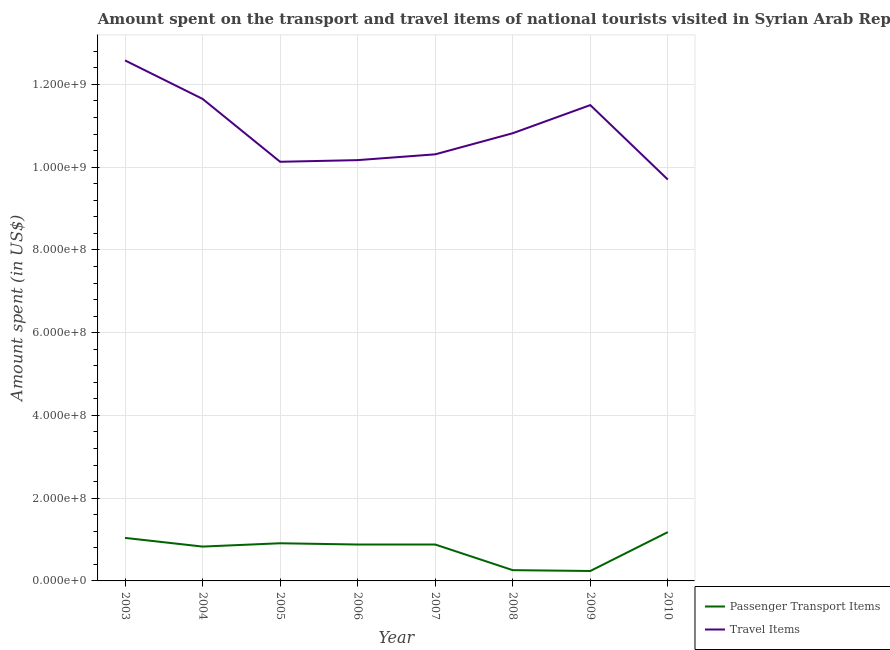Is the number of lines equal to the number of legend labels?
Provide a succinct answer. Yes. What is the amount spent in travel items in 2003?
Offer a terse response. 1.26e+09. Across all years, what is the maximum amount spent on passenger transport items?
Offer a terse response. 1.18e+08. Across all years, what is the minimum amount spent on passenger transport items?
Your answer should be compact. 2.40e+07. In which year was the amount spent on passenger transport items maximum?
Offer a very short reply. 2010. In which year was the amount spent on passenger transport items minimum?
Your response must be concise. 2009. What is the total amount spent on passenger transport items in the graph?
Provide a short and direct response. 6.22e+08. What is the difference between the amount spent in travel items in 2003 and that in 2006?
Ensure brevity in your answer.  2.41e+08. What is the difference between the amount spent on passenger transport items in 2007 and the amount spent in travel items in 2005?
Your response must be concise. -9.25e+08. What is the average amount spent in travel items per year?
Your answer should be very brief. 1.09e+09. In the year 2010, what is the difference between the amount spent in travel items and amount spent on passenger transport items?
Offer a terse response. 8.52e+08. What is the ratio of the amount spent in travel items in 2006 to that in 2007?
Provide a short and direct response. 0.99. Is the difference between the amount spent in travel items in 2003 and 2010 greater than the difference between the amount spent on passenger transport items in 2003 and 2010?
Provide a succinct answer. Yes. What is the difference between the highest and the second highest amount spent on passenger transport items?
Ensure brevity in your answer.  1.40e+07. What is the difference between the highest and the lowest amount spent on passenger transport items?
Offer a terse response. 9.40e+07. In how many years, is the amount spent on passenger transport items greater than the average amount spent on passenger transport items taken over all years?
Keep it short and to the point. 6. Is the sum of the amount spent in travel items in 2003 and 2005 greater than the maximum amount spent on passenger transport items across all years?
Offer a terse response. Yes. Does the amount spent in travel items monotonically increase over the years?
Provide a short and direct response. No. How many years are there in the graph?
Provide a succinct answer. 8. Are the values on the major ticks of Y-axis written in scientific E-notation?
Offer a terse response. Yes. Where does the legend appear in the graph?
Keep it short and to the point. Bottom right. What is the title of the graph?
Your answer should be very brief. Amount spent on the transport and travel items of national tourists visited in Syrian Arab Republic. Does "GDP at market prices" appear as one of the legend labels in the graph?
Your answer should be compact. No. What is the label or title of the Y-axis?
Your answer should be compact. Amount spent (in US$). What is the Amount spent (in US$) of Passenger Transport Items in 2003?
Ensure brevity in your answer.  1.04e+08. What is the Amount spent (in US$) in Travel Items in 2003?
Your response must be concise. 1.26e+09. What is the Amount spent (in US$) in Passenger Transport Items in 2004?
Your answer should be compact. 8.30e+07. What is the Amount spent (in US$) in Travel Items in 2004?
Provide a succinct answer. 1.16e+09. What is the Amount spent (in US$) of Passenger Transport Items in 2005?
Give a very brief answer. 9.10e+07. What is the Amount spent (in US$) of Travel Items in 2005?
Your response must be concise. 1.01e+09. What is the Amount spent (in US$) of Passenger Transport Items in 2006?
Ensure brevity in your answer.  8.80e+07. What is the Amount spent (in US$) of Travel Items in 2006?
Provide a short and direct response. 1.02e+09. What is the Amount spent (in US$) of Passenger Transport Items in 2007?
Make the answer very short. 8.80e+07. What is the Amount spent (in US$) of Travel Items in 2007?
Provide a succinct answer. 1.03e+09. What is the Amount spent (in US$) in Passenger Transport Items in 2008?
Make the answer very short. 2.60e+07. What is the Amount spent (in US$) of Travel Items in 2008?
Offer a very short reply. 1.08e+09. What is the Amount spent (in US$) of Passenger Transport Items in 2009?
Provide a succinct answer. 2.40e+07. What is the Amount spent (in US$) of Travel Items in 2009?
Offer a very short reply. 1.15e+09. What is the Amount spent (in US$) in Passenger Transport Items in 2010?
Provide a succinct answer. 1.18e+08. What is the Amount spent (in US$) in Travel Items in 2010?
Make the answer very short. 9.70e+08. Across all years, what is the maximum Amount spent (in US$) of Passenger Transport Items?
Offer a very short reply. 1.18e+08. Across all years, what is the maximum Amount spent (in US$) of Travel Items?
Keep it short and to the point. 1.26e+09. Across all years, what is the minimum Amount spent (in US$) in Passenger Transport Items?
Offer a very short reply. 2.40e+07. Across all years, what is the minimum Amount spent (in US$) in Travel Items?
Keep it short and to the point. 9.70e+08. What is the total Amount spent (in US$) of Passenger Transport Items in the graph?
Make the answer very short. 6.22e+08. What is the total Amount spent (in US$) of Travel Items in the graph?
Offer a terse response. 8.69e+09. What is the difference between the Amount spent (in US$) of Passenger Transport Items in 2003 and that in 2004?
Offer a terse response. 2.10e+07. What is the difference between the Amount spent (in US$) in Travel Items in 2003 and that in 2004?
Make the answer very short. 9.30e+07. What is the difference between the Amount spent (in US$) of Passenger Transport Items in 2003 and that in 2005?
Your answer should be compact. 1.30e+07. What is the difference between the Amount spent (in US$) of Travel Items in 2003 and that in 2005?
Offer a very short reply. 2.45e+08. What is the difference between the Amount spent (in US$) of Passenger Transport Items in 2003 and that in 2006?
Give a very brief answer. 1.60e+07. What is the difference between the Amount spent (in US$) of Travel Items in 2003 and that in 2006?
Keep it short and to the point. 2.41e+08. What is the difference between the Amount spent (in US$) of Passenger Transport Items in 2003 and that in 2007?
Your answer should be very brief. 1.60e+07. What is the difference between the Amount spent (in US$) in Travel Items in 2003 and that in 2007?
Your answer should be very brief. 2.27e+08. What is the difference between the Amount spent (in US$) of Passenger Transport Items in 2003 and that in 2008?
Offer a very short reply. 7.80e+07. What is the difference between the Amount spent (in US$) of Travel Items in 2003 and that in 2008?
Keep it short and to the point. 1.76e+08. What is the difference between the Amount spent (in US$) in Passenger Transport Items in 2003 and that in 2009?
Give a very brief answer. 8.00e+07. What is the difference between the Amount spent (in US$) of Travel Items in 2003 and that in 2009?
Your answer should be compact. 1.08e+08. What is the difference between the Amount spent (in US$) of Passenger Transport Items in 2003 and that in 2010?
Give a very brief answer. -1.40e+07. What is the difference between the Amount spent (in US$) of Travel Items in 2003 and that in 2010?
Make the answer very short. 2.88e+08. What is the difference between the Amount spent (in US$) in Passenger Transport Items in 2004 and that in 2005?
Keep it short and to the point. -8.00e+06. What is the difference between the Amount spent (in US$) of Travel Items in 2004 and that in 2005?
Keep it short and to the point. 1.52e+08. What is the difference between the Amount spent (in US$) of Passenger Transport Items in 2004 and that in 2006?
Ensure brevity in your answer.  -5.00e+06. What is the difference between the Amount spent (in US$) in Travel Items in 2004 and that in 2006?
Provide a short and direct response. 1.48e+08. What is the difference between the Amount spent (in US$) of Passenger Transport Items in 2004 and that in 2007?
Your answer should be compact. -5.00e+06. What is the difference between the Amount spent (in US$) of Travel Items in 2004 and that in 2007?
Make the answer very short. 1.34e+08. What is the difference between the Amount spent (in US$) of Passenger Transport Items in 2004 and that in 2008?
Offer a terse response. 5.70e+07. What is the difference between the Amount spent (in US$) of Travel Items in 2004 and that in 2008?
Ensure brevity in your answer.  8.30e+07. What is the difference between the Amount spent (in US$) of Passenger Transport Items in 2004 and that in 2009?
Give a very brief answer. 5.90e+07. What is the difference between the Amount spent (in US$) in Travel Items in 2004 and that in 2009?
Give a very brief answer. 1.50e+07. What is the difference between the Amount spent (in US$) in Passenger Transport Items in 2004 and that in 2010?
Your answer should be very brief. -3.50e+07. What is the difference between the Amount spent (in US$) of Travel Items in 2004 and that in 2010?
Provide a succinct answer. 1.95e+08. What is the difference between the Amount spent (in US$) in Travel Items in 2005 and that in 2007?
Ensure brevity in your answer.  -1.80e+07. What is the difference between the Amount spent (in US$) of Passenger Transport Items in 2005 and that in 2008?
Provide a succinct answer. 6.50e+07. What is the difference between the Amount spent (in US$) in Travel Items in 2005 and that in 2008?
Provide a succinct answer. -6.90e+07. What is the difference between the Amount spent (in US$) of Passenger Transport Items in 2005 and that in 2009?
Ensure brevity in your answer.  6.70e+07. What is the difference between the Amount spent (in US$) of Travel Items in 2005 and that in 2009?
Your answer should be very brief. -1.37e+08. What is the difference between the Amount spent (in US$) of Passenger Transport Items in 2005 and that in 2010?
Provide a short and direct response. -2.70e+07. What is the difference between the Amount spent (in US$) of Travel Items in 2005 and that in 2010?
Offer a very short reply. 4.30e+07. What is the difference between the Amount spent (in US$) of Passenger Transport Items in 2006 and that in 2007?
Give a very brief answer. 0. What is the difference between the Amount spent (in US$) in Travel Items in 2006 and that in 2007?
Provide a short and direct response. -1.40e+07. What is the difference between the Amount spent (in US$) of Passenger Transport Items in 2006 and that in 2008?
Give a very brief answer. 6.20e+07. What is the difference between the Amount spent (in US$) of Travel Items in 2006 and that in 2008?
Ensure brevity in your answer.  -6.50e+07. What is the difference between the Amount spent (in US$) of Passenger Transport Items in 2006 and that in 2009?
Give a very brief answer. 6.40e+07. What is the difference between the Amount spent (in US$) of Travel Items in 2006 and that in 2009?
Your response must be concise. -1.33e+08. What is the difference between the Amount spent (in US$) in Passenger Transport Items in 2006 and that in 2010?
Make the answer very short. -3.00e+07. What is the difference between the Amount spent (in US$) in Travel Items in 2006 and that in 2010?
Make the answer very short. 4.70e+07. What is the difference between the Amount spent (in US$) of Passenger Transport Items in 2007 and that in 2008?
Offer a very short reply. 6.20e+07. What is the difference between the Amount spent (in US$) of Travel Items in 2007 and that in 2008?
Keep it short and to the point. -5.10e+07. What is the difference between the Amount spent (in US$) of Passenger Transport Items in 2007 and that in 2009?
Offer a terse response. 6.40e+07. What is the difference between the Amount spent (in US$) in Travel Items in 2007 and that in 2009?
Keep it short and to the point. -1.19e+08. What is the difference between the Amount spent (in US$) of Passenger Transport Items in 2007 and that in 2010?
Your answer should be compact. -3.00e+07. What is the difference between the Amount spent (in US$) of Travel Items in 2007 and that in 2010?
Your answer should be compact. 6.10e+07. What is the difference between the Amount spent (in US$) of Passenger Transport Items in 2008 and that in 2009?
Your answer should be very brief. 2.00e+06. What is the difference between the Amount spent (in US$) of Travel Items in 2008 and that in 2009?
Keep it short and to the point. -6.80e+07. What is the difference between the Amount spent (in US$) of Passenger Transport Items in 2008 and that in 2010?
Offer a very short reply. -9.20e+07. What is the difference between the Amount spent (in US$) in Travel Items in 2008 and that in 2010?
Your response must be concise. 1.12e+08. What is the difference between the Amount spent (in US$) of Passenger Transport Items in 2009 and that in 2010?
Keep it short and to the point. -9.40e+07. What is the difference between the Amount spent (in US$) of Travel Items in 2009 and that in 2010?
Your answer should be very brief. 1.80e+08. What is the difference between the Amount spent (in US$) of Passenger Transport Items in 2003 and the Amount spent (in US$) of Travel Items in 2004?
Your answer should be compact. -1.06e+09. What is the difference between the Amount spent (in US$) of Passenger Transport Items in 2003 and the Amount spent (in US$) of Travel Items in 2005?
Ensure brevity in your answer.  -9.09e+08. What is the difference between the Amount spent (in US$) of Passenger Transport Items in 2003 and the Amount spent (in US$) of Travel Items in 2006?
Provide a short and direct response. -9.13e+08. What is the difference between the Amount spent (in US$) of Passenger Transport Items in 2003 and the Amount spent (in US$) of Travel Items in 2007?
Provide a short and direct response. -9.27e+08. What is the difference between the Amount spent (in US$) of Passenger Transport Items in 2003 and the Amount spent (in US$) of Travel Items in 2008?
Your answer should be very brief. -9.78e+08. What is the difference between the Amount spent (in US$) in Passenger Transport Items in 2003 and the Amount spent (in US$) in Travel Items in 2009?
Provide a short and direct response. -1.05e+09. What is the difference between the Amount spent (in US$) in Passenger Transport Items in 2003 and the Amount spent (in US$) in Travel Items in 2010?
Keep it short and to the point. -8.66e+08. What is the difference between the Amount spent (in US$) of Passenger Transport Items in 2004 and the Amount spent (in US$) of Travel Items in 2005?
Provide a succinct answer. -9.30e+08. What is the difference between the Amount spent (in US$) in Passenger Transport Items in 2004 and the Amount spent (in US$) in Travel Items in 2006?
Your answer should be compact. -9.34e+08. What is the difference between the Amount spent (in US$) in Passenger Transport Items in 2004 and the Amount spent (in US$) in Travel Items in 2007?
Offer a terse response. -9.48e+08. What is the difference between the Amount spent (in US$) of Passenger Transport Items in 2004 and the Amount spent (in US$) of Travel Items in 2008?
Offer a very short reply. -9.99e+08. What is the difference between the Amount spent (in US$) of Passenger Transport Items in 2004 and the Amount spent (in US$) of Travel Items in 2009?
Give a very brief answer. -1.07e+09. What is the difference between the Amount spent (in US$) of Passenger Transport Items in 2004 and the Amount spent (in US$) of Travel Items in 2010?
Your answer should be very brief. -8.87e+08. What is the difference between the Amount spent (in US$) in Passenger Transport Items in 2005 and the Amount spent (in US$) in Travel Items in 2006?
Ensure brevity in your answer.  -9.26e+08. What is the difference between the Amount spent (in US$) of Passenger Transport Items in 2005 and the Amount spent (in US$) of Travel Items in 2007?
Make the answer very short. -9.40e+08. What is the difference between the Amount spent (in US$) in Passenger Transport Items in 2005 and the Amount spent (in US$) in Travel Items in 2008?
Your answer should be compact. -9.91e+08. What is the difference between the Amount spent (in US$) of Passenger Transport Items in 2005 and the Amount spent (in US$) of Travel Items in 2009?
Your response must be concise. -1.06e+09. What is the difference between the Amount spent (in US$) in Passenger Transport Items in 2005 and the Amount spent (in US$) in Travel Items in 2010?
Provide a succinct answer. -8.79e+08. What is the difference between the Amount spent (in US$) of Passenger Transport Items in 2006 and the Amount spent (in US$) of Travel Items in 2007?
Provide a short and direct response. -9.43e+08. What is the difference between the Amount spent (in US$) in Passenger Transport Items in 2006 and the Amount spent (in US$) in Travel Items in 2008?
Offer a terse response. -9.94e+08. What is the difference between the Amount spent (in US$) of Passenger Transport Items in 2006 and the Amount spent (in US$) of Travel Items in 2009?
Keep it short and to the point. -1.06e+09. What is the difference between the Amount spent (in US$) of Passenger Transport Items in 2006 and the Amount spent (in US$) of Travel Items in 2010?
Give a very brief answer. -8.82e+08. What is the difference between the Amount spent (in US$) in Passenger Transport Items in 2007 and the Amount spent (in US$) in Travel Items in 2008?
Your answer should be compact. -9.94e+08. What is the difference between the Amount spent (in US$) of Passenger Transport Items in 2007 and the Amount spent (in US$) of Travel Items in 2009?
Make the answer very short. -1.06e+09. What is the difference between the Amount spent (in US$) of Passenger Transport Items in 2007 and the Amount spent (in US$) of Travel Items in 2010?
Make the answer very short. -8.82e+08. What is the difference between the Amount spent (in US$) of Passenger Transport Items in 2008 and the Amount spent (in US$) of Travel Items in 2009?
Offer a terse response. -1.12e+09. What is the difference between the Amount spent (in US$) of Passenger Transport Items in 2008 and the Amount spent (in US$) of Travel Items in 2010?
Offer a very short reply. -9.44e+08. What is the difference between the Amount spent (in US$) in Passenger Transport Items in 2009 and the Amount spent (in US$) in Travel Items in 2010?
Offer a terse response. -9.46e+08. What is the average Amount spent (in US$) in Passenger Transport Items per year?
Your answer should be compact. 7.78e+07. What is the average Amount spent (in US$) of Travel Items per year?
Provide a succinct answer. 1.09e+09. In the year 2003, what is the difference between the Amount spent (in US$) of Passenger Transport Items and Amount spent (in US$) of Travel Items?
Your answer should be compact. -1.15e+09. In the year 2004, what is the difference between the Amount spent (in US$) in Passenger Transport Items and Amount spent (in US$) in Travel Items?
Your response must be concise. -1.08e+09. In the year 2005, what is the difference between the Amount spent (in US$) in Passenger Transport Items and Amount spent (in US$) in Travel Items?
Your response must be concise. -9.22e+08. In the year 2006, what is the difference between the Amount spent (in US$) in Passenger Transport Items and Amount spent (in US$) in Travel Items?
Make the answer very short. -9.29e+08. In the year 2007, what is the difference between the Amount spent (in US$) in Passenger Transport Items and Amount spent (in US$) in Travel Items?
Your response must be concise. -9.43e+08. In the year 2008, what is the difference between the Amount spent (in US$) in Passenger Transport Items and Amount spent (in US$) in Travel Items?
Give a very brief answer. -1.06e+09. In the year 2009, what is the difference between the Amount spent (in US$) in Passenger Transport Items and Amount spent (in US$) in Travel Items?
Keep it short and to the point. -1.13e+09. In the year 2010, what is the difference between the Amount spent (in US$) in Passenger Transport Items and Amount spent (in US$) in Travel Items?
Provide a short and direct response. -8.52e+08. What is the ratio of the Amount spent (in US$) of Passenger Transport Items in 2003 to that in 2004?
Keep it short and to the point. 1.25. What is the ratio of the Amount spent (in US$) in Travel Items in 2003 to that in 2004?
Provide a short and direct response. 1.08. What is the ratio of the Amount spent (in US$) of Travel Items in 2003 to that in 2005?
Make the answer very short. 1.24. What is the ratio of the Amount spent (in US$) in Passenger Transport Items in 2003 to that in 2006?
Give a very brief answer. 1.18. What is the ratio of the Amount spent (in US$) in Travel Items in 2003 to that in 2006?
Provide a succinct answer. 1.24. What is the ratio of the Amount spent (in US$) of Passenger Transport Items in 2003 to that in 2007?
Make the answer very short. 1.18. What is the ratio of the Amount spent (in US$) in Travel Items in 2003 to that in 2007?
Your answer should be compact. 1.22. What is the ratio of the Amount spent (in US$) in Passenger Transport Items in 2003 to that in 2008?
Provide a short and direct response. 4. What is the ratio of the Amount spent (in US$) in Travel Items in 2003 to that in 2008?
Provide a succinct answer. 1.16. What is the ratio of the Amount spent (in US$) in Passenger Transport Items in 2003 to that in 2009?
Offer a very short reply. 4.33. What is the ratio of the Amount spent (in US$) of Travel Items in 2003 to that in 2009?
Your response must be concise. 1.09. What is the ratio of the Amount spent (in US$) of Passenger Transport Items in 2003 to that in 2010?
Your answer should be very brief. 0.88. What is the ratio of the Amount spent (in US$) of Travel Items in 2003 to that in 2010?
Offer a very short reply. 1.3. What is the ratio of the Amount spent (in US$) in Passenger Transport Items in 2004 to that in 2005?
Make the answer very short. 0.91. What is the ratio of the Amount spent (in US$) of Travel Items in 2004 to that in 2005?
Offer a very short reply. 1.15. What is the ratio of the Amount spent (in US$) of Passenger Transport Items in 2004 to that in 2006?
Provide a succinct answer. 0.94. What is the ratio of the Amount spent (in US$) in Travel Items in 2004 to that in 2006?
Ensure brevity in your answer.  1.15. What is the ratio of the Amount spent (in US$) in Passenger Transport Items in 2004 to that in 2007?
Give a very brief answer. 0.94. What is the ratio of the Amount spent (in US$) of Travel Items in 2004 to that in 2007?
Your response must be concise. 1.13. What is the ratio of the Amount spent (in US$) in Passenger Transport Items in 2004 to that in 2008?
Your response must be concise. 3.19. What is the ratio of the Amount spent (in US$) in Travel Items in 2004 to that in 2008?
Your response must be concise. 1.08. What is the ratio of the Amount spent (in US$) of Passenger Transport Items in 2004 to that in 2009?
Provide a succinct answer. 3.46. What is the ratio of the Amount spent (in US$) of Travel Items in 2004 to that in 2009?
Provide a succinct answer. 1.01. What is the ratio of the Amount spent (in US$) of Passenger Transport Items in 2004 to that in 2010?
Provide a succinct answer. 0.7. What is the ratio of the Amount spent (in US$) of Travel Items in 2004 to that in 2010?
Make the answer very short. 1.2. What is the ratio of the Amount spent (in US$) in Passenger Transport Items in 2005 to that in 2006?
Ensure brevity in your answer.  1.03. What is the ratio of the Amount spent (in US$) in Passenger Transport Items in 2005 to that in 2007?
Provide a short and direct response. 1.03. What is the ratio of the Amount spent (in US$) in Travel Items in 2005 to that in 2007?
Your response must be concise. 0.98. What is the ratio of the Amount spent (in US$) of Passenger Transport Items in 2005 to that in 2008?
Provide a succinct answer. 3.5. What is the ratio of the Amount spent (in US$) in Travel Items in 2005 to that in 2008?
Your answer should be compact. 0.94. What is the ratio of the Amount spent (in US$) in Passenger Transport Items in 2005 to that in 2009?
Your answer should be very brief. 3.79. What is the ratio of the Amount spent (in US$) in Travel Items in 2005 to that in 2009?
Your answer should be very brief. 0.88. What is the ratio of the Amount spent (in US$) of Passenger Transport Items in 2005 to that in 2010?
Your answer should be very brief. 0.77. What is the ratio of the Amount spent (in US$) of Travel Items in 2005 to that in 2010?
Keep it short and to the point. 1.04. What is the ratio of the Amount spent (in US$) in Travel Items in 2006 to that in 2007?
Offer a very short reply. 0.99. What is the ratio of the Amount spent (in US$) of Passenger Transport Items in 2006 to that in 2008?
Offer a very short reply. 3.38. What is the ratio of the Amount spent (in US$) in Travel Items in 2006 to that in 2008?
Your response must be concise. 0.94. What is the ratio of the Amount spent (in US$) of Passenger Transport Items in 2006 to that in 2009?
Make the answer very short. 3.67. What is the ratio of the Amount spent (in US$) in Travel Items in 2006 to that in 2009?
Provide a short and direct response. 0.88. What is the ratio of the Amount spent (in US$) in Passenger Transport Items in 2006 to that in 2010?
Keep it short and to the point. 0.75. What is the ratio of the Amount spent (in US$) in Travel Items in 2006 to that in 2010?
Provide a short and direct response. 1.05. What is the ratio of the Amount spent (in US$) in Passenger Transport Items in 2007 to that in 2008?
Give a very brief answer. 3.38. What is the ratio of the Amount spent (in US$) of Travel Items in 2007 to that in 2008?
Your answer should be very brief. 0.95. What is the ratio of the Amount spent (in US$) in Passenger Transport Items in 2007 to that in 2009?
Make the answer very short. 3.67. What is the ratio of the Amount spent (in US$) in Travel Items in 2007 to that in 2009?
Offer a terse response. 0.9. What is the ratio of the Amount spent (in US$) of Passenger Transport Items in 2007 to that in 2010?
Provide a succinct answer. 0.75. What is the ratio of the Amount spent (in US$) of Travel Items in 2007 to that in 2010?
Give a very brief answer. 1.06. What is the ratio of the Amount spent (in US$) in Passenger Transport Items in 2008 to that in 2009?
Your answer should be compact. 1.08. What is the ratio of the Amount spent (in US$) of Travel Items in 2008 to that in 2009?
Keep it short and to the point. 0.94. What is the ratio of the Amount spent (in US$) in Passenger Transport Items in 2008 to that in 2010?
Provide a short and direct response. 0.22. What is the ratio of the Amount spent (in US$) of Travel Items in 2008 to that in 2010?
Your response must be concise. 1.12. What is the ratio of the Amount spent (in US$) in Passenger Transport Items in 2009 to that in 2010?
Ensure brevity in your answer.  0.2. What is the ratio of the Amount spent (in US$) of Travel Items in 2009 to that in 2010?
Offer a terse response. 1.19. What is the difference between the highest and the second highest Amount spent (in US$) in Passenger Transport Items?
Provide a short and direct response. 1.40e+07. What is the difference between the highest and the second highest Amount spent (in US$) in Travel Items?
Give a very brief answer. 9.30e+07. What is the difference between the highest and the lowest Amount spent (in US$) in Passenger Transport Items?
Offer a very short reply. 9.40e+07. What is the difference between the highest and the lowest Amount spent (in US$) of Travel Items?
Ensure brevity in your answer.  2.88e+08. 